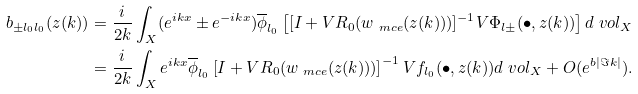<formula> <loc_0><loc_0><loc_500><loc_500>b _ { \pm l _ { 0 } l _ { 0 } } ( z ( k ) ) & = \frac { i } { 2 k } \int _ { X } ( e ^ { i k x } \pm e ^ { - i k x } ) \overline { \phi } _ { l _ { 0 } } \left [ [ I + V R _ { 0 } ( w _ { \ m c e } ( z ( k ) ) ) ] ^ { - 1 } V \Phi _ { l \pm } ( \bullet , z ( k ) ) \right ] d \ v o l _ { X } \\ & = \frac { i } { 2 k } \int _ { X } e ^ { i k x } \overline { \phi } _ { l _ { 0 } } \left [ I + V R _ { 0 } ( w _ { \ m c e } ( z ( k ) ) ) \right ] ^ { - 1 } V f _ { l _ { 0 } } ( \bullet , z ( k ) ) d \ v o l _ { X } + O ( e ^ { b | \Im k | } ) .</formula> 